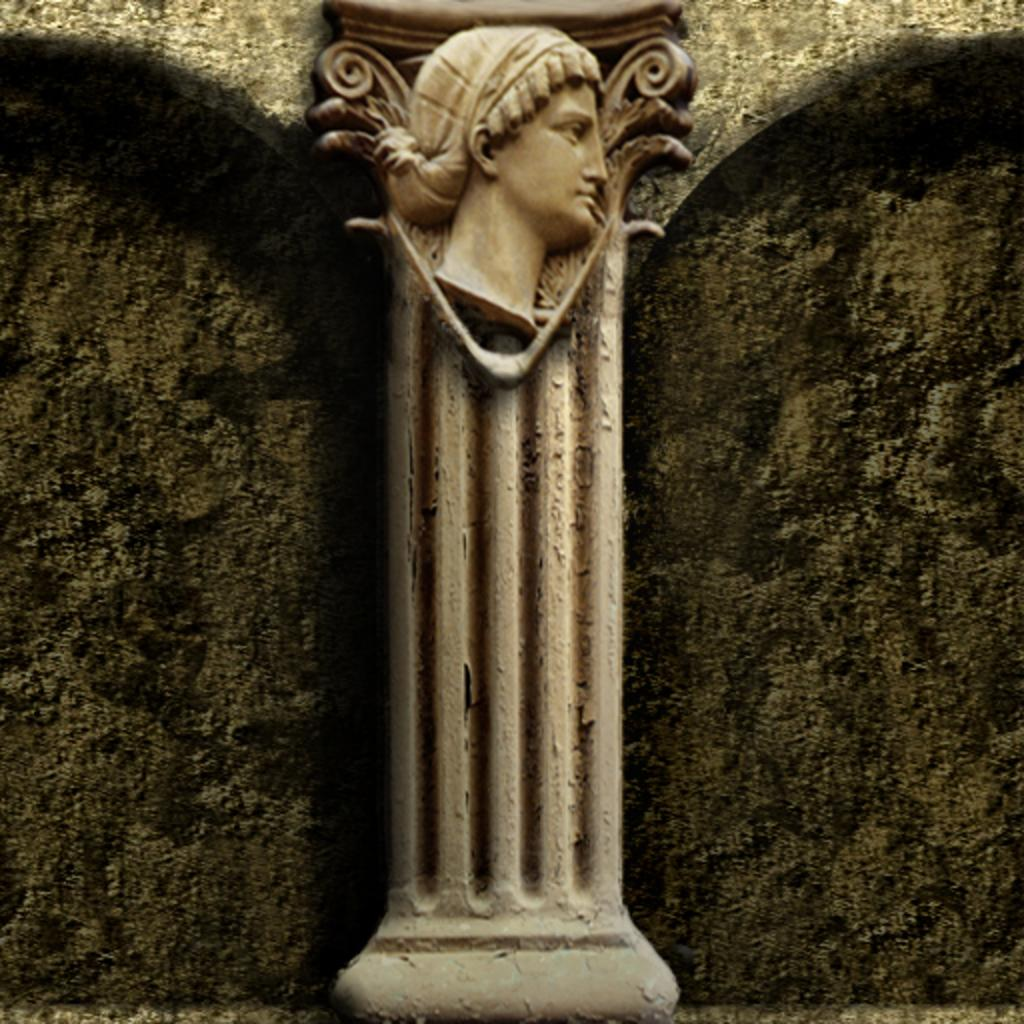What is the main structure visible in the image? There is a pillar in the image. What is on top of or attached to the pillar? There is a sculpture on the pillar. What type of spark can be seen coming from the machine in the image? There is no machine present in the image, and therefore no sparks can be observed. 